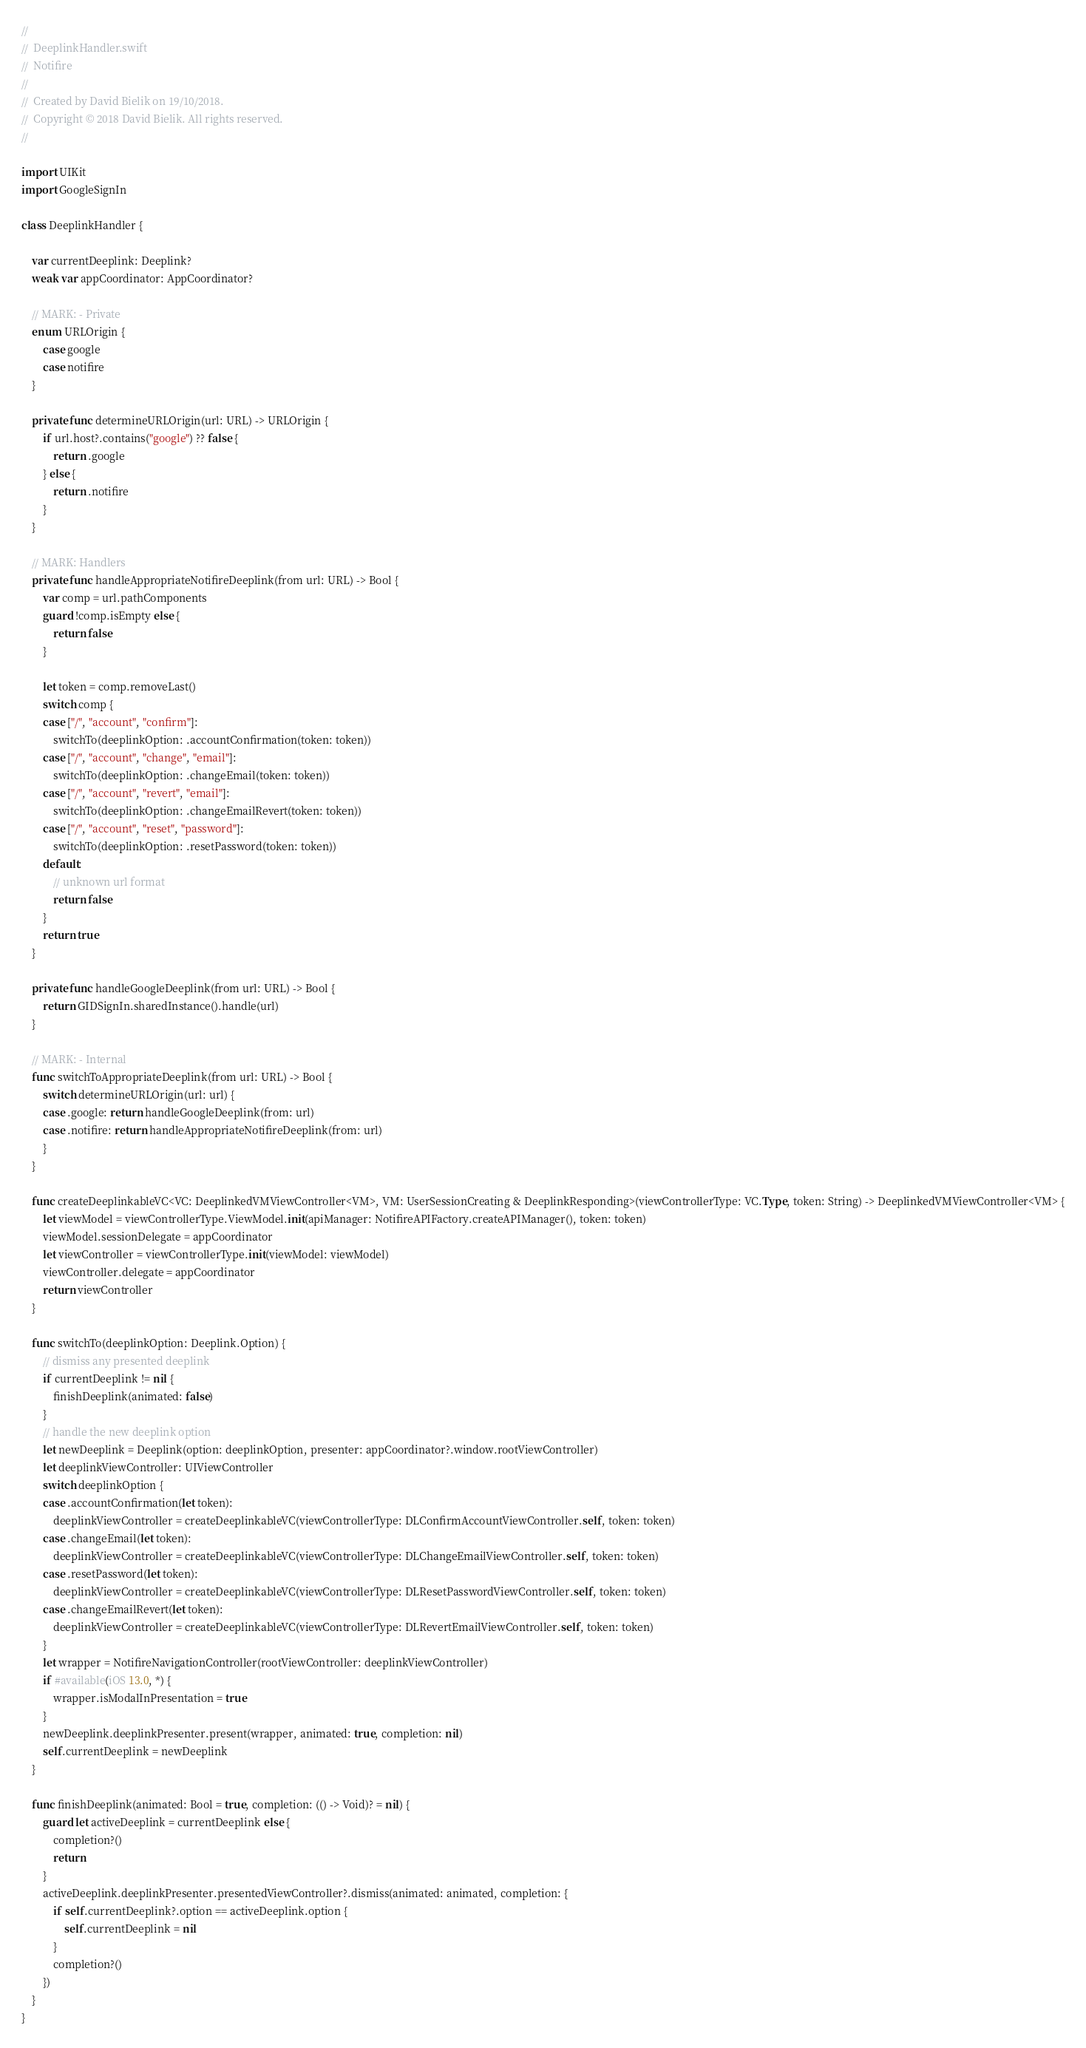Convert code to text. <code><loc_0><loc_0><loc_500><loc_500><_Swift_>//
//  DeeplinkHandler.swift
//  Notifire
//
//  Created by David Bielik on 19/10/2018.
//  Copyright © 2018 David Bielik. All rights reserved.
//

import UIKit
import GoogleSignIn

class DeeplinkHandler {

    var currentDeeplink: Deeplink?
    weak var appCoordinator: AppCoordinator?

    // MARK: - Private
    enum URLOrigin {
        case google
        case notifire
    }

    private func determineURLOrigin(url: URL) -> URLOrigin {
        if url.host?.contains("google") ?? false {
            return .google
        } else {
            return .notifire
        }
    }

    // MARK: Handlers
    private func handleAppropriateNotifireDeeplink(from url: URL) -> Bool {
        var comp = url.pathComponents
        guard !comp.isEmpty else {
            return false
        }

        let token = comp.removeLast()
        switch comp {
        case ["/", "account", "confirm"]:
            switchTo(deeplinkOption: .accountConfirmation(token: token))
        case ["/", "account", "change", "email"]:
            switchTo(deeplinkOption: .changeEmail(token: token))
        case ["/", "account", "revert", "email"]:
            switchTo(deeplinkOption: .changeEmailRevert(token: token))
        case ["/", "account", "reset", "password"]:
            switchTo(deeplinkOption: .resetPassword(token: token))
        default:
            // unknown url format
            return false
        }
        return true
    }

    private func handleGoogleDeeplink(from url: URL) -> Bool {
        return GIDSignIn.sharedInstance().handle(url)
    }

    // MARK: - Internal
    func switchToAppropriateDeeplink(from url: URL) -> Bool {
        switch determineURLOrigin(url: url) {
        case .google: return handleGoogleDeeplink(from: url)
        case .notifire: return handleAppropriateNotifireDeeplink(from: url)
        }
    }

    func createDeeplinkableVC<VC: DeeplinkedVMViewController<VM>, VM: UserSessionCreating & DeeplinkResponding>(viewControllerType: VC.Type, token: String) -> DeeplinkedVMViewController<VM> {
        let viewModel = viewControllerType.ViewModel.init(apiManager: NotifireAPIFactory.createAPIManager(), token: token)
        viewModel.sessionDelegate = appCoordinator
        let viewController = viewControllerType.init(viewModel: viewModel)
        viewController.delegate = appCoordinator
        return viewController
    }

    func switchTo(deeplinkOption: Deeplink.Option) {
        // dismiss any presented deeplink
        if currentDeeplink != nil {
            finishDeeplink(animated: false)
        }
        // handle the new deeplink option
        let newDeeplink = Deeplink(option: deeplinkOption, presenter: appCoordinator?.window.rootViewController)
        let deeplinkViewController: UIViewController
        switch deeplinkOption {
        case .accountConfirmation(let token):
            deeplinkViewController = createDeeplinkableVC(viewControllerType: DLConfirmAccountViewController.self, token: token)
        case .changeEmail(let token):
            deeplinkViewController = createDeeplinkableVC(viewControllerType: DLChangeEmailViewController.self, token: token)
        case .resetPassword(let token):
            deeplinkViewController = createDeeplinkableVC(viewControllerType: DLResetPasswordViewController.self, token: token)
        case .changeEmailRevert(let token):
            deeplinkViewController = createDeeplinkableVC(viewControllerType: DLRevertEmailViewController.self, token: token)
        }
        let wrapper = NotifireNavigationController(rootViewController: deeplinkViewController)
        if #available(iOS 13.0, *) {
            wrapper.isModalInPresentation = true
        }
        newDeeplink.deeplinkPresenter.present(wrapper, animated: true, completion: nil)
        self.currentDeeplink = newDeeplink
    }

    func finishDeeplink(animated: Bool = true, completion: (() -> Void)? = nil) {
        guard let activeDeeplink = currentDeeplink else {
            completion?()
            return
        }
        activeDeeplink.deeplinkPresenter.presentedViewController?.dismiss(animated: animated, completion: {
            if self.currentDeeplink?.option == activeDeeplink.option {
                self.currentDeeplink = nil
            }
            completion?()
        })
    }
}
</code> 